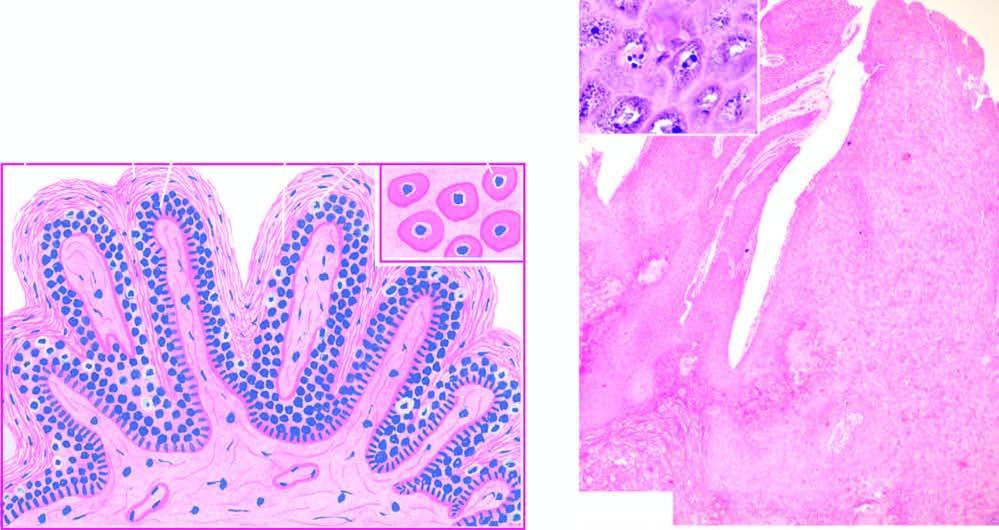what does inset show?
Answer the question using a single word or phrase. Koilocytes and virus-infected keratinocytes containing prominent keratohyaline granules 